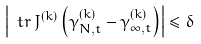<formula> <loc_0><loc_0><loc_500><loc_500>\left | \ t r \, J ^ { ( k ) } \left ( \gamma _ { N , t } ^ { ( k ) } - \gamma ^ { ( k ) } _ { \infty , t } \right ) \right | \leq \delta</formula> 